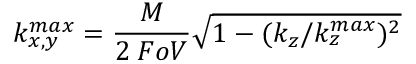<formula> <loc_0><loc_0><loc_500><loc_500>k _ { x , y } ^ { \max } = \frac { M } { 2 \, F o V } \sqrt { 1 - ( k _ { z } / k _ { z } ^ { \max } ) ^ { 2 } }</formula> 